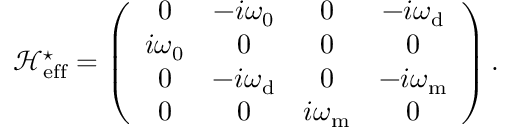<formula> <loc_0><loc_0><loc_500><loc_500>\mathcal { H } _ { e f f } ^ { ^ { * } } = \left ( \begin{array} { c c c c } { 0 } & { - i \omega _ { 0 } } & { 0 } & { - i \omega _ { d } } \\ { i \omega _ { 0 } } & { 0 } & { 0 } & { 0 } \\ { 0 } & { - i \omega _ { d } } & { 0 } & { - i { \omega } _ { m } } \\ { 0 } & { 0 } & { i { \omega } _ { m } } & { 0 } \end{array} \right ) .</formula> 